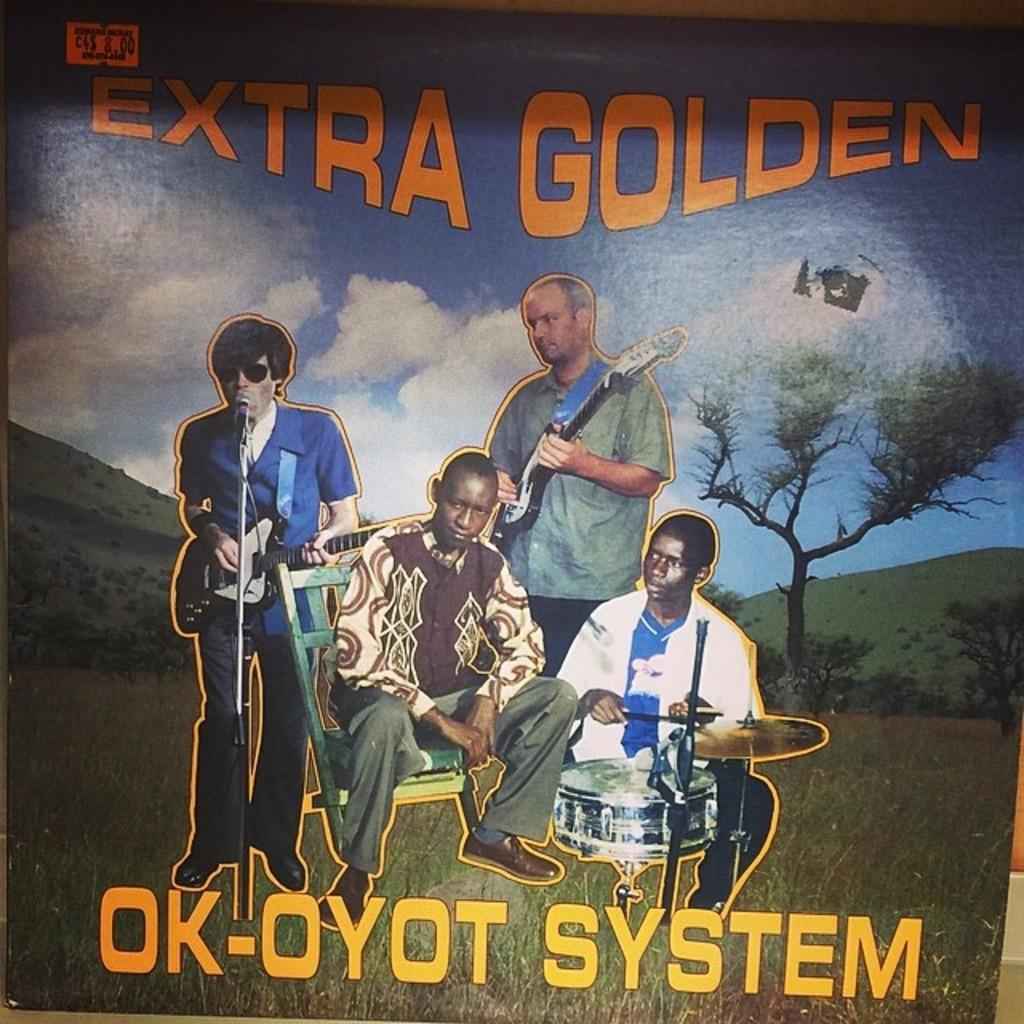<image>
Present a compact description of the photo's key features. A record or cd cover called Extra Golden is showed with a picture of the band Ok-Oyot System on it. 